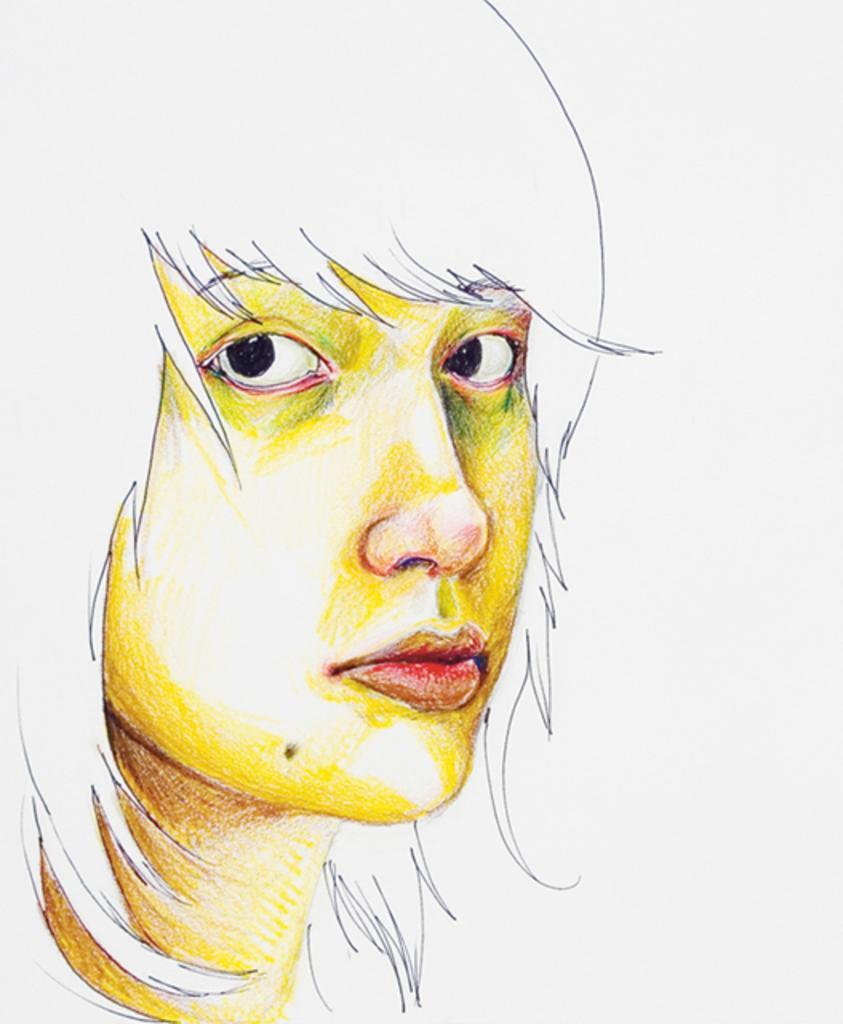Describe this image in one or two sentences. This is the drawing of a girl. The background is white. 